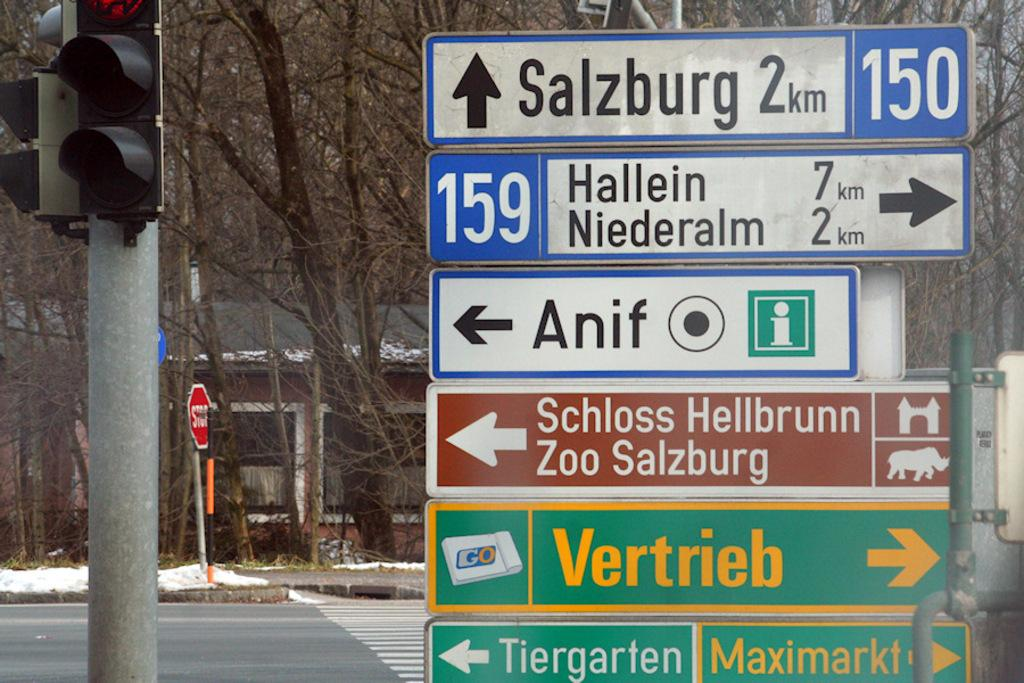<image>
Provide a brief description of the given image. a sign with the word vertrieb on it 